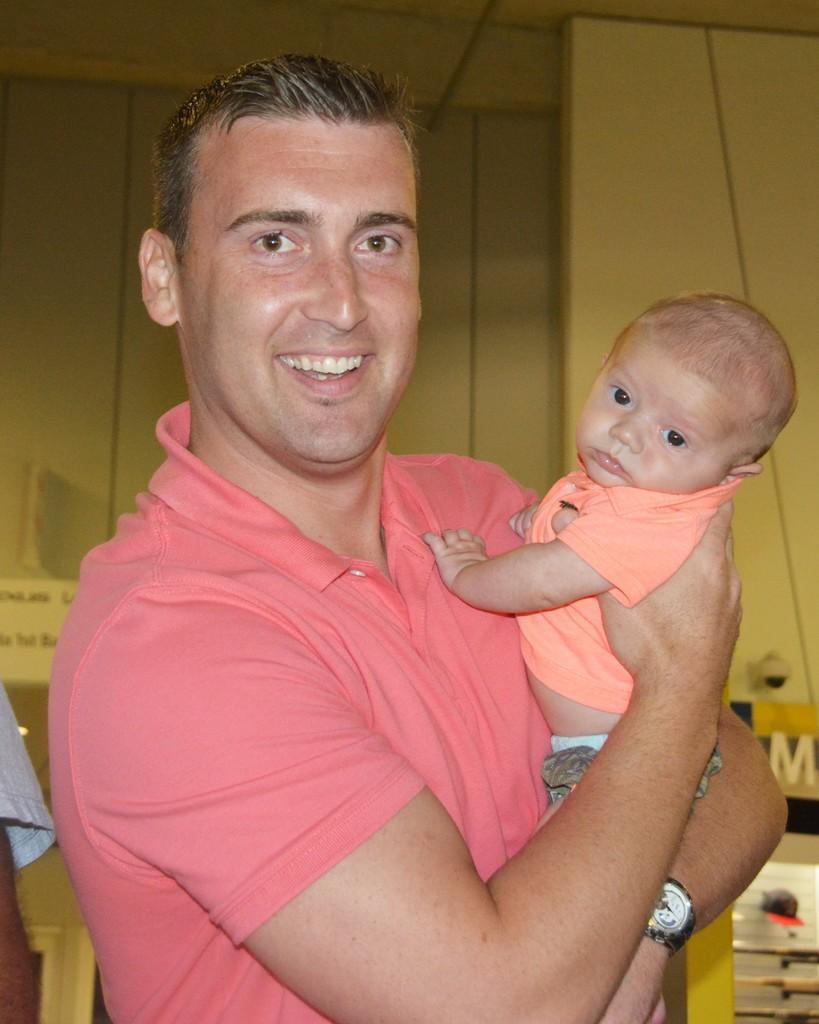What is the man in the image doing? The man in the image is carrying a baby. What can be seen in the background of the image? There is a wall and a switch board in the background of the image. What type of jeans is the baby wearing in the image? There is no information about the baby's clothing in the image, so we cannot determine if they are wearing jeans or any other type of clothing. 